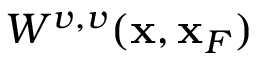Convert formula to latex. <formula><loc_0><loc_0><loc_500><loc_500>W ^ { v , v } ( { x } , { x } _ { F } )</formula> 